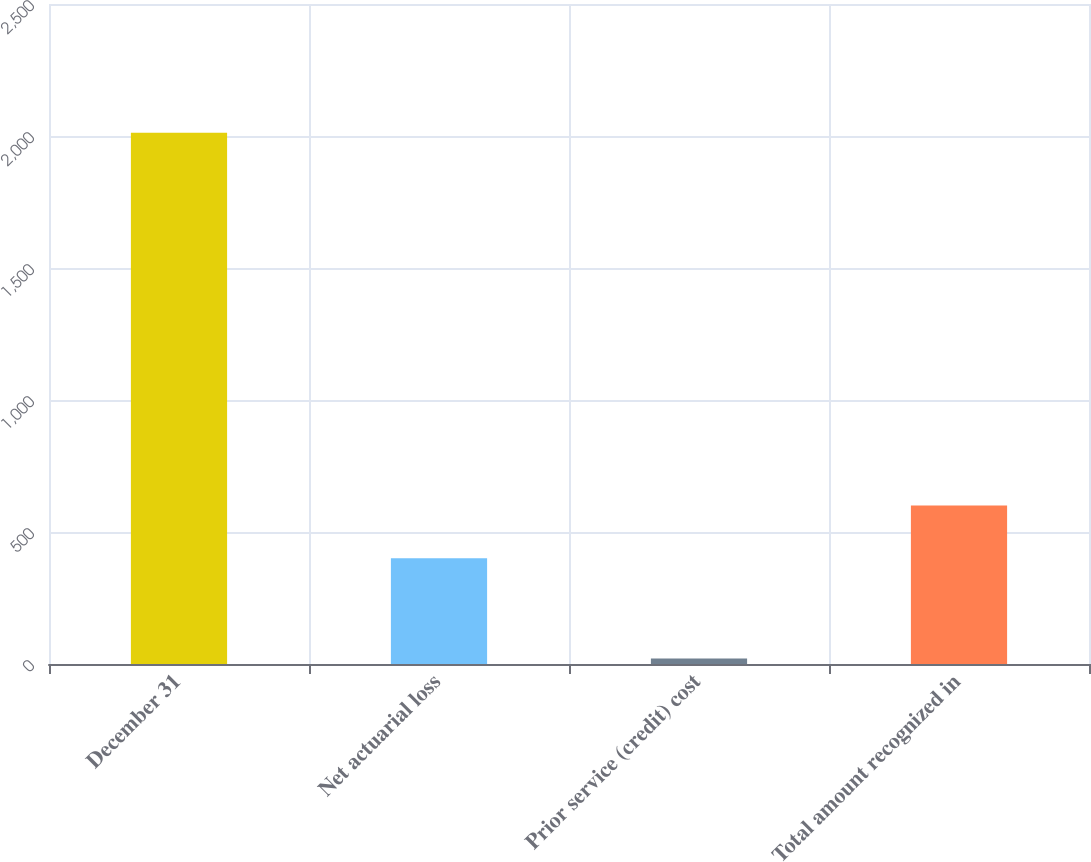<chart> <loc_0><loc_0><loc_500><loc_500><bar_chart><fcel>December 31<fcel>Net actuarial loss<fcel>Prior service (credit) cost<fcel>Total amount recognized in<nl><fcel>2012<fcel>401<fcel>21<fcel>600.1<nl></chart> 